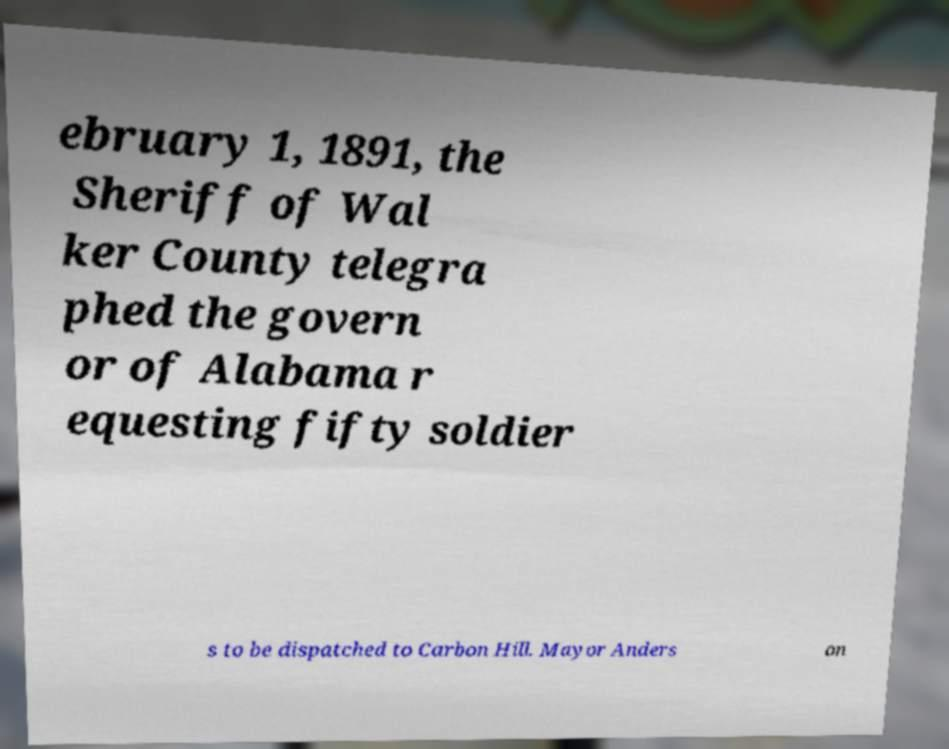Could you extract and type out the text from this image? ebruary 1, 1891, the Sheriff of Wal ker County telegra phed the govern or of Alabama r equesting fifty soldier s to be dispatched to Carbon Hill. Mayor Anders on 